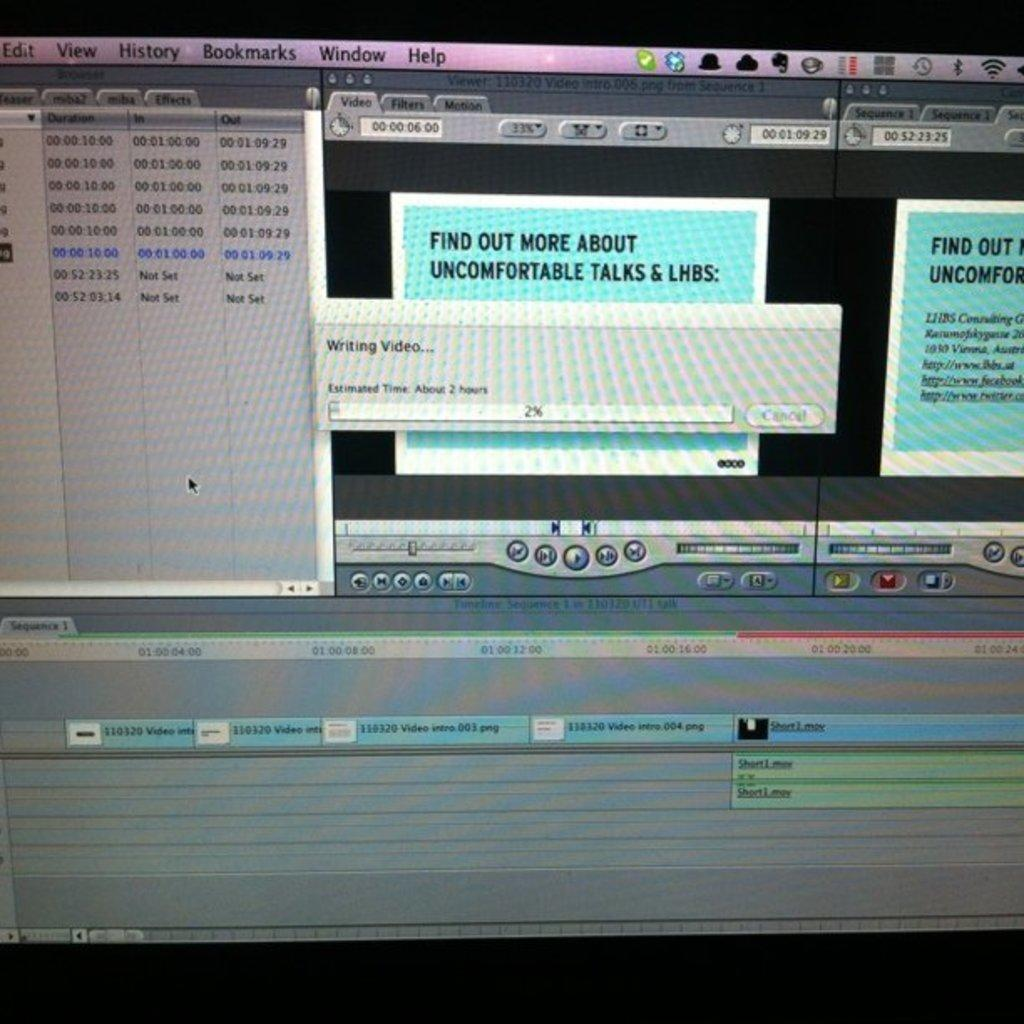<image>
Provide a brief description of the given image. A computer screen displaying a program that has a tab open that says Find Out More About Uncomfortable Talks & LHBS 